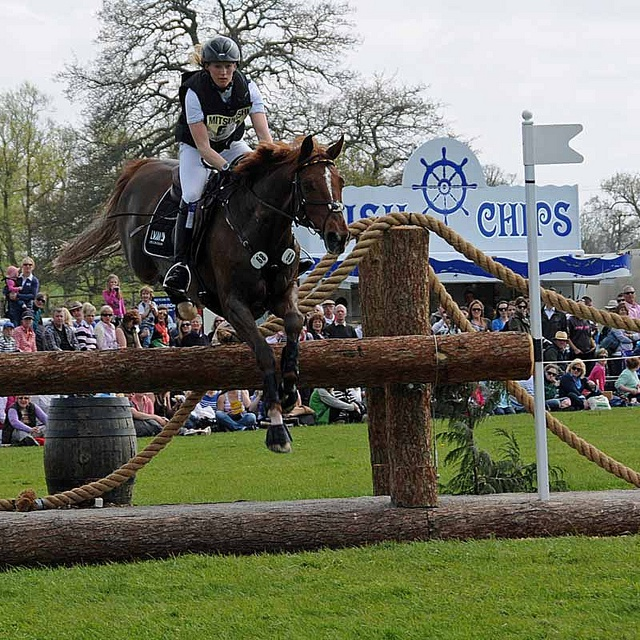Describe the objects in this image and their specific colors. I can see horse in white, black, gray, and maroon tones, people in white, black, gray, darkgray, and darkgreen tones, people in white, black, gray, and darkgray tones, people in white, black, gray, and darkgray tones, and people in white, black, gray, and maroon tones in this image. 